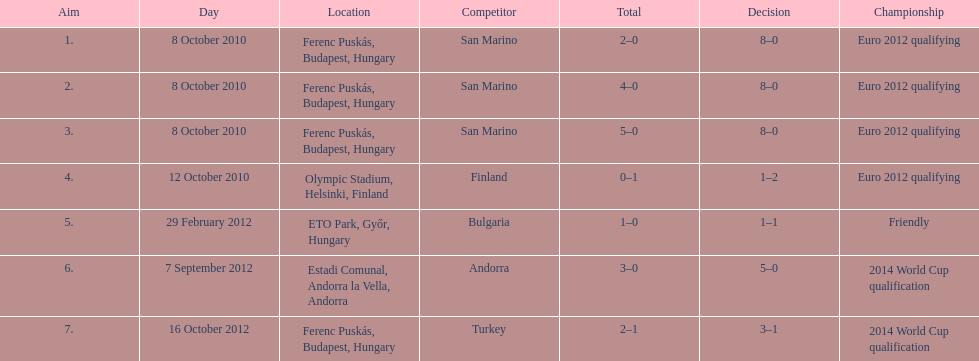How many international goals has ádám szalai netted in total? 7. 